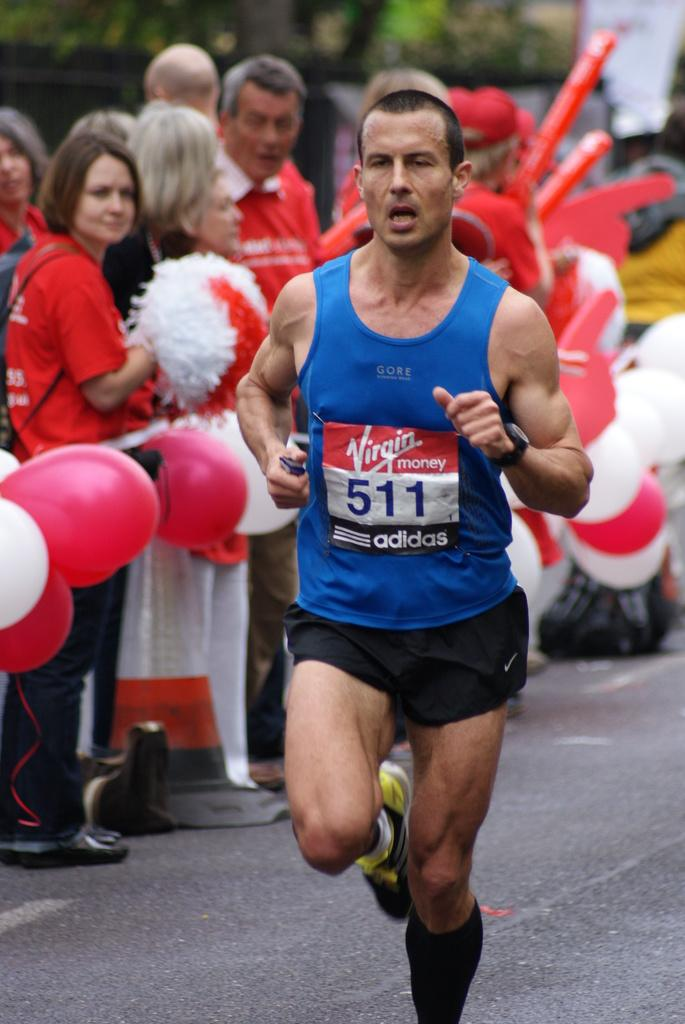<image>
Share a concise interpretation of the image provided. a runner for a marathon wearing sponsorings of virgin money 511 and adidas 